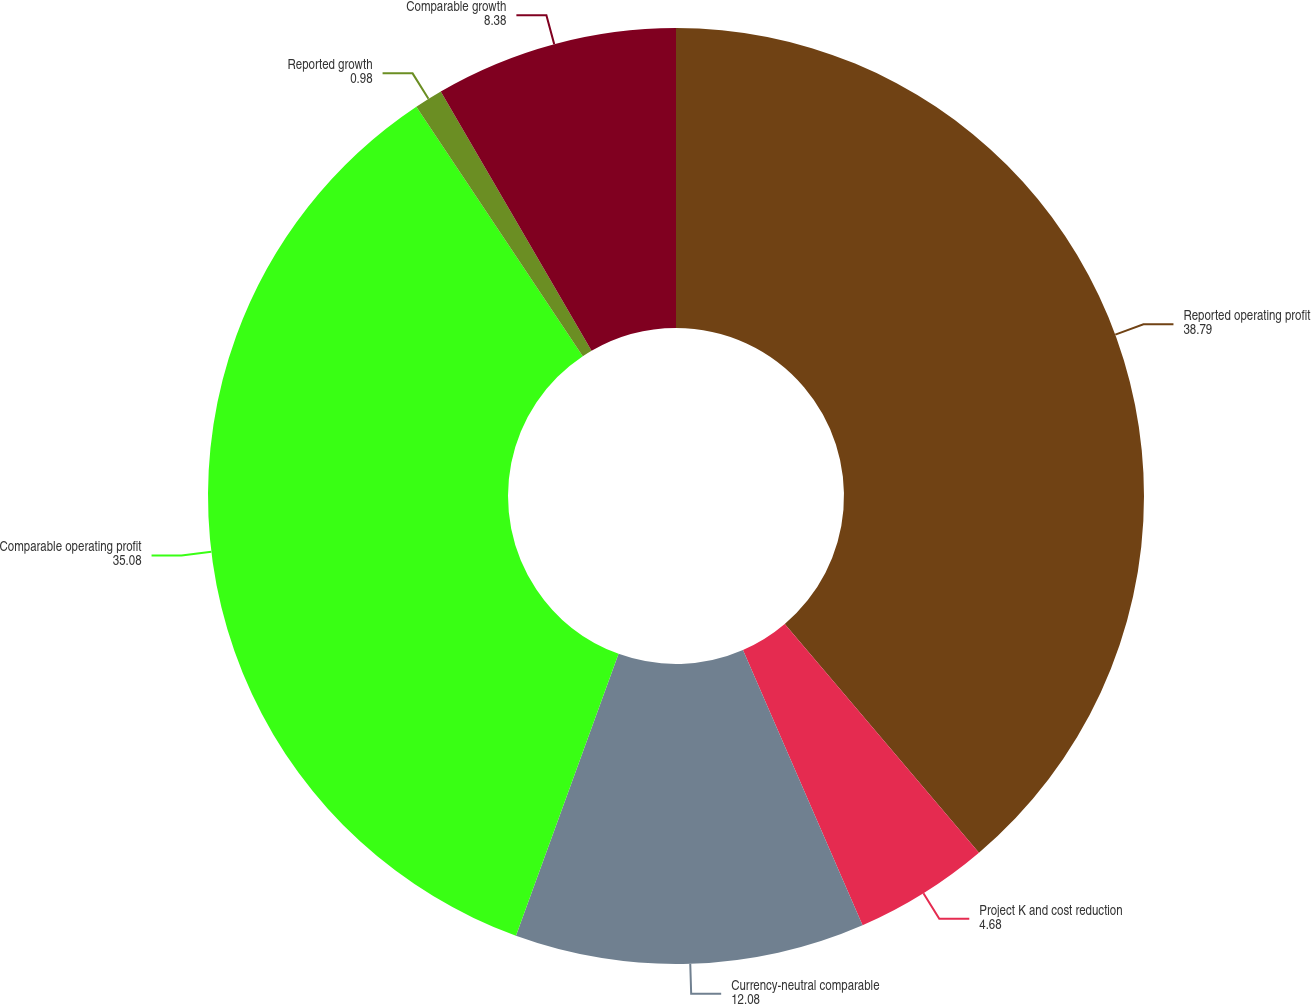<chart> <loc_0><loc_0><loc_500><loc_500><pie_chart><fcel>Reported operating profit<fcel>Project K and cost reduction<fcel>Currency-neutral comparable<fcel>Comparable operating profit<fcel>Reported growth<fcel>Comparable growth<nl><fcel>38.79%<fcel>4.68%<fcel>12.08%<fcel>35.08%<fcel>0.98%<fcel>8.38%<nl></chart> 